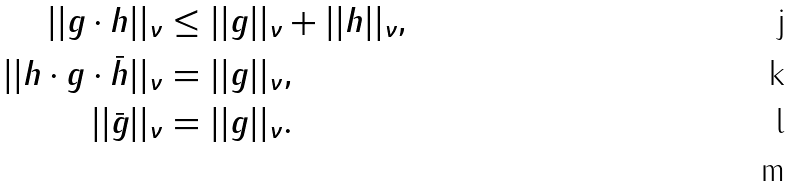<formula> <loc_0><loc_0><loc_500><loc_500>| | g \cdot h | | _ { \nu } & \leq | | g | | _ { \nu } + | | h | | _ { \nu } , \\ | | h \cdot g \cdot \bar { h } | | _ { \nu } & = | | g | | _ { \nu } , \\ | | \bar { g } | | _ { \nu } & = | | g | | _ { \nu } . \\</formula> 